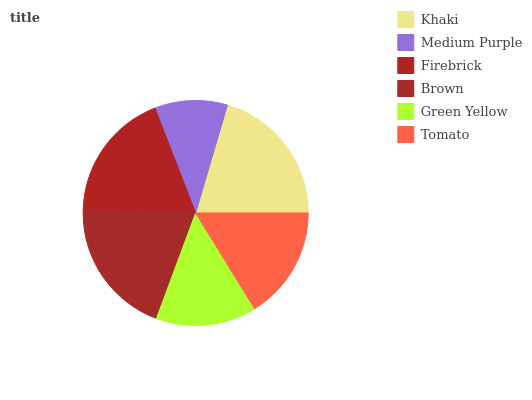Is Medium Purple the minimum?
Answer yes or no. Yes. Is Khaki the maximum?
Answer yes or no. Yes. Is Firebrick the minimum?
Answer yes or no. No. Is Firebrick the maximum?
Answer yes or no. No. Is Firebrick greater than Medium Purple?
Answer yes or no. Yes. Is Medium Purple less than Firebrick?
Answer yes or no. Yes. Is Medium Purple greater than Firebrick?
Answer yes or no. No. Is Firebrick less than Medium Purple?
Answer yes or no. No. Is Firebrick the high median?
Answer yes or no. Yes. Is Tomato the low median?
Answer yes or no. Yes. Is Tomato the high median?
Answer yes or no. No. Is Brown the low median?
Answer yes or no. No. 